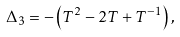Convert formula to latex. <formula><loc_0><loc_0><loc_500><loc_500>\Delta _ { 3 } = - \left ( T ^ { 2 } - 2 T + T ^ { - 1 } \right ) ,</formula> 